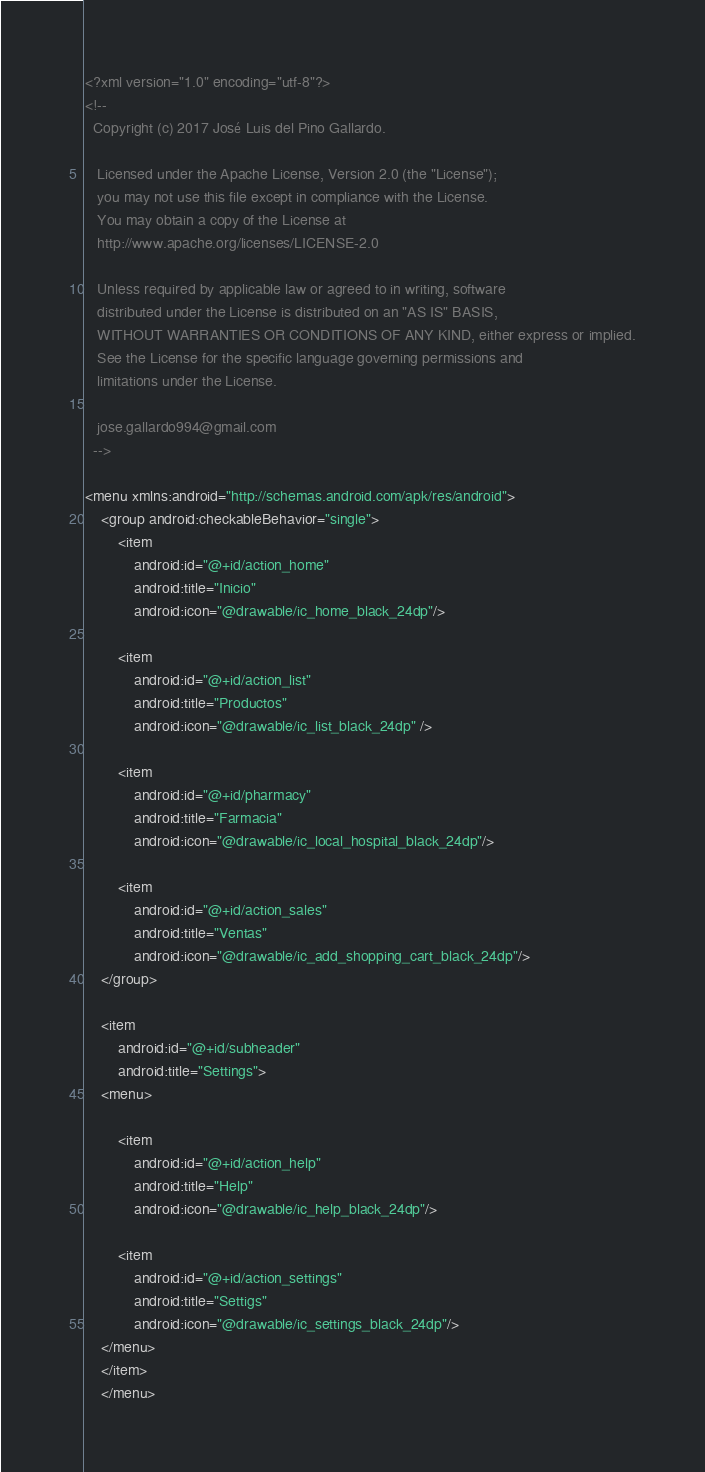<code> <loc_0><loc_0><loc_500><loc_500><_XML_><?xml version="1.0" encoding="utf-8"?>
<!--
  Copyright (c) 2017 José Luis del Pino Gallardo.

   Licensed under the Apache License, Version 2.0 (the "License");
   you may not use this file except in compliance with the License.
   You may obtain a copy of the License at
   http://www.apache.org/licenses/LICENSE-2.0

   Unless required by applicable law or agreed to in writing, software
   distributed under the License is distributed on an "AS IS" BASIS,
   WITHOUT WARRANTIES OR CONDITIONS OF ANY KIND, either express or implied.
   See the License for the specific language governing permissions and
   limitations under the License.

   jose.gallardo994@gmail.com
  -->

<menu xmlns:android="http://schemas.android.com/apk/res/android">
    <group android:checkableBehavior="single">
        <item
            android:id="@+id/action_home"
            android:title="Inicio"
            android:icon="@drawable/ic_home_black_24dp"/>

        <item
            android:id="@+id/action_list"
            android:title="Productos"
            android:icon="@drawable/ic_list_black_24dp" />

        <item
            android:id="@+id/pharmacy"
            android:title="Farmacia"
            android:icon="@drawable/ic_local_hospital_black_24dp"/>

        <item
            android:id="@+id/action_sales"
            android:title="Ventas"
            android:icon="@drawable/ic_add_shopping_cart_black_24dp"/>
    </group>

    <item
        android:id="@+id/subheader"
        android:title="Settings">
    <menu>

        <item
            android:id="@+id/action_help"
            android:title="Help"
            android:icon="@drawable/ic_help_black_24dp"/>

        <item
            android:id="@+id/action_settings"
            android:title="Settigs"
            android:icon="@drawable/ic_settings_black_24dp"/>
    </menu>
    </item>
    </menu>


</code> 